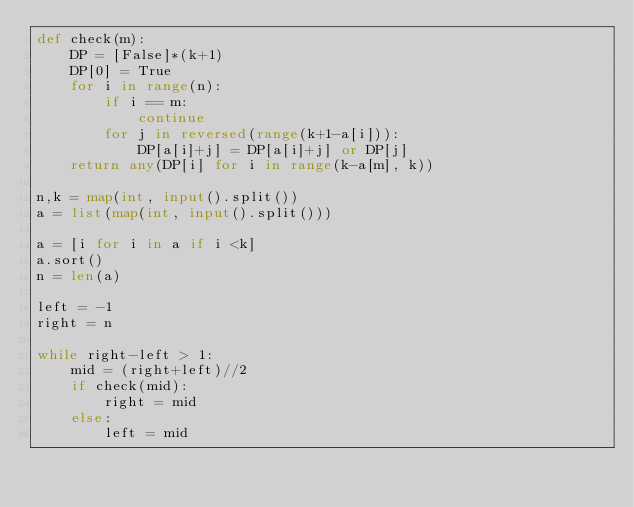<code> <loc_0><loc_0><loc_500><loc_500><_Python_>def check(m):
    DP = [False]*(k+1)
    DP[0] = True
    for i in range(n):
        if i == m:
            continue
        for j in reversed(range(k+1-a[i])):
            DP[a[i]+j] = DP[a[i]+j] or DP[j]
    return any(DP[i] for i in range(k-a[m], k))

n,k = map(int, input().split())
a = list(map(int, input().split()))

a = [i for i in a if i <k]
a.sort()
n = len(a)

left = -1
right = n

while right-left > 1:
    mid = (right+left)//2
    if check(mid):
        right = mid
    else:
        left = mid
</code> 